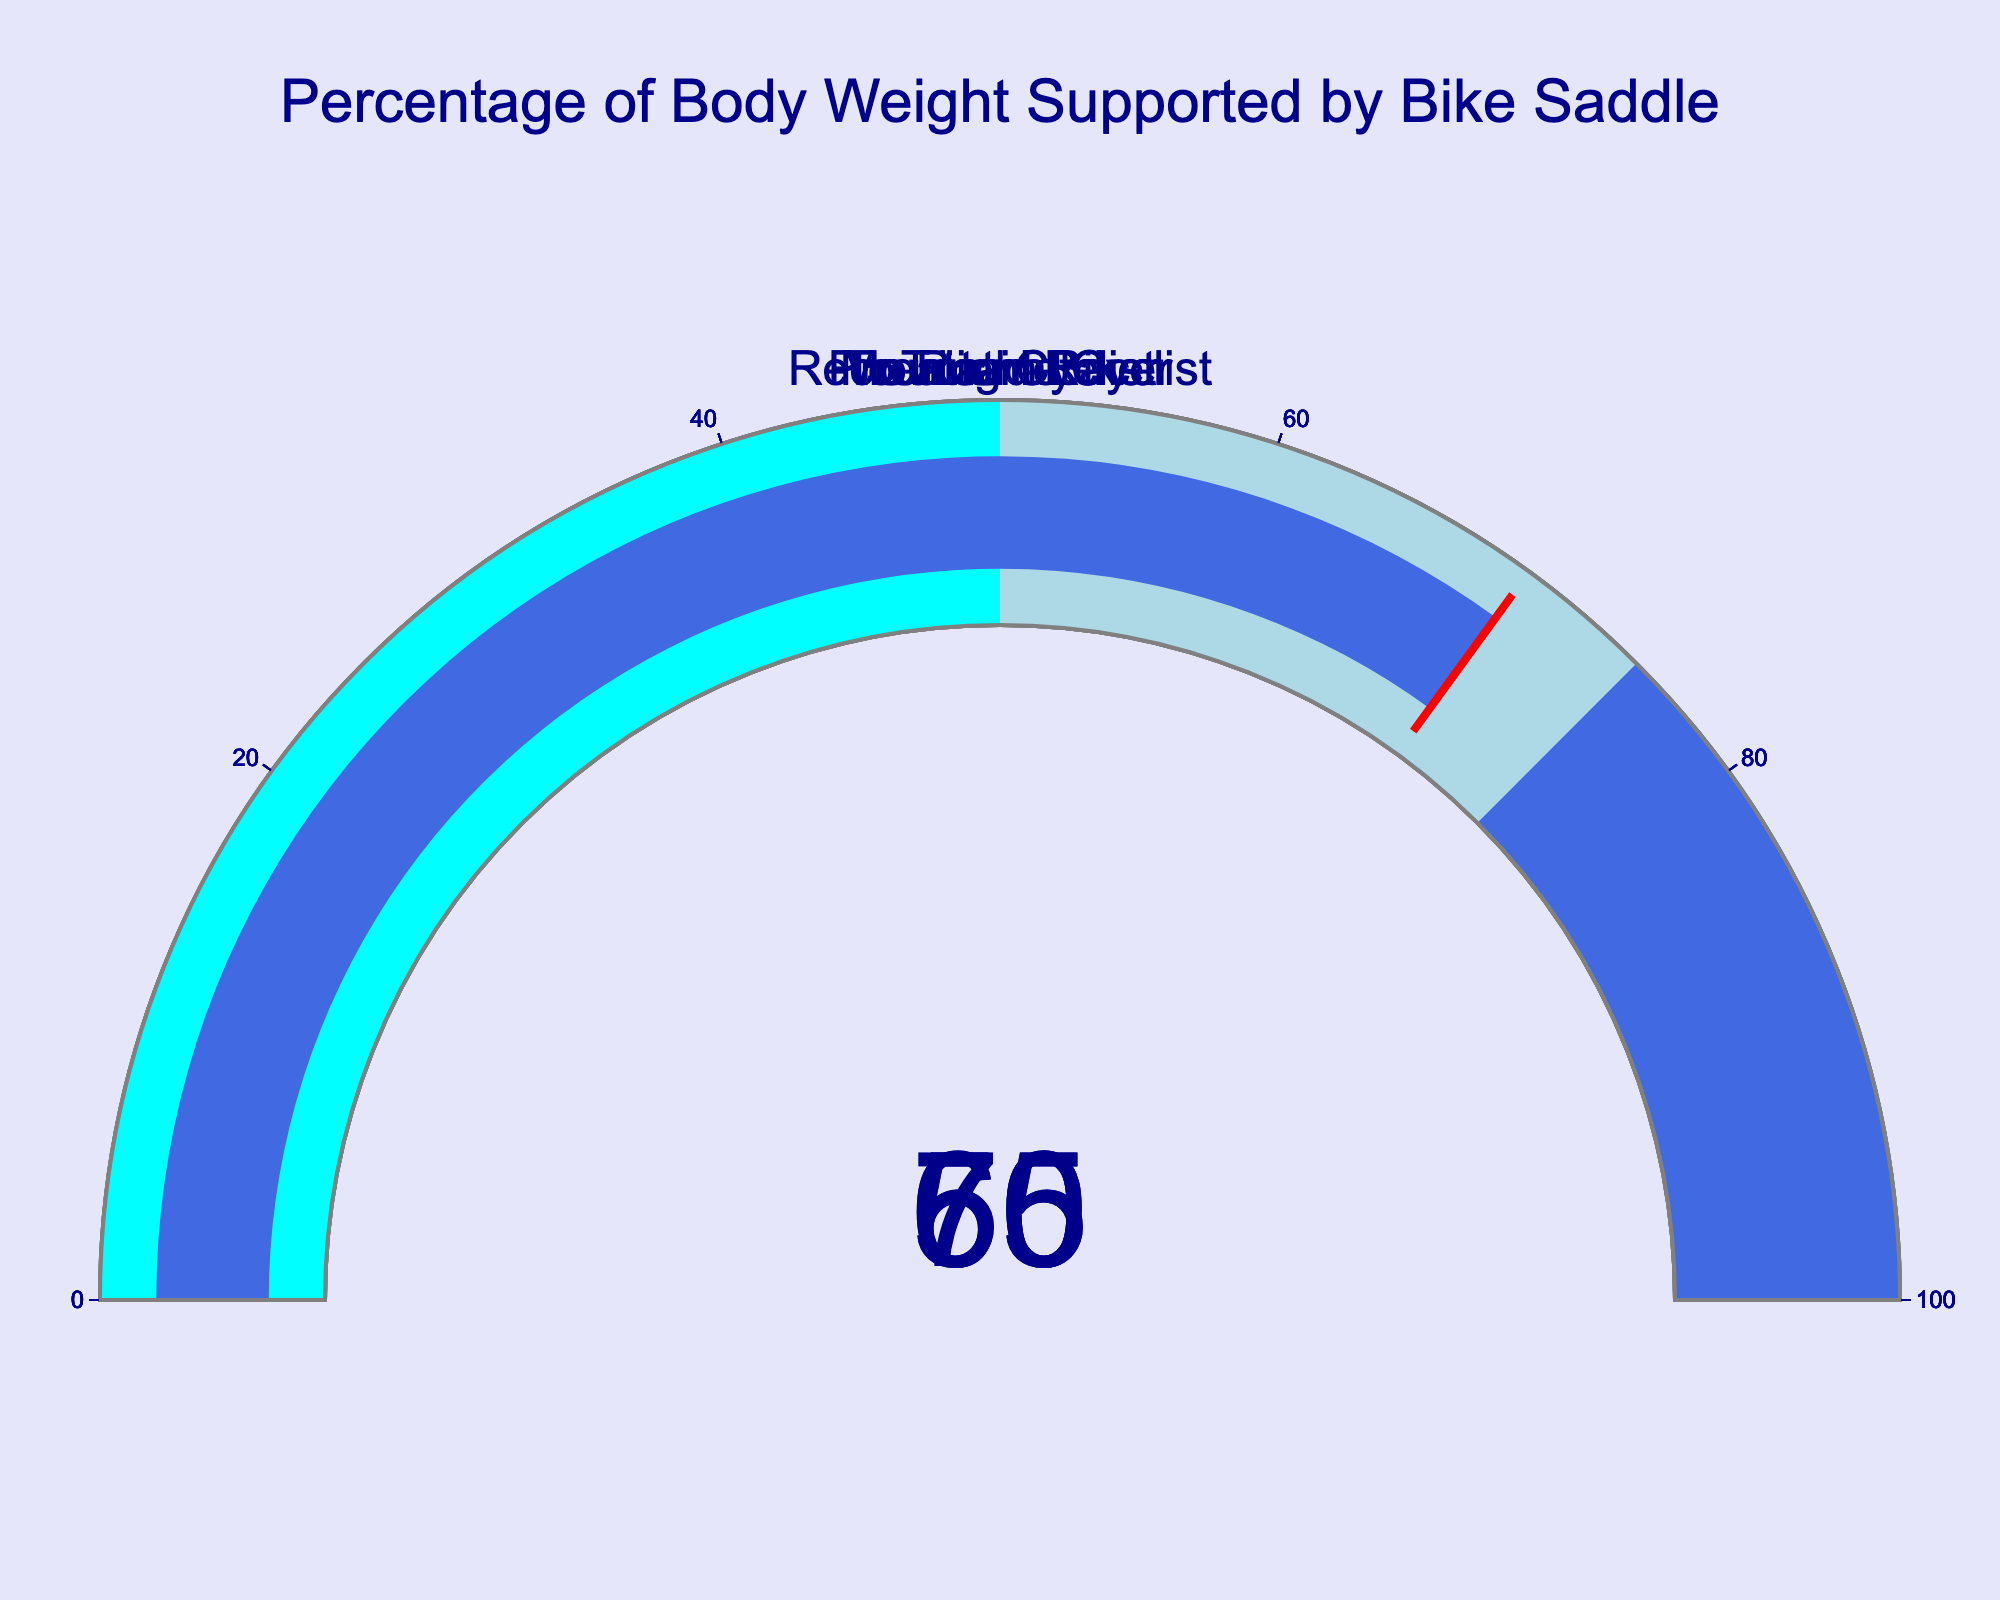Which cyclist type has the highest percentage of body weight supported by the saddle? To determine this, we have to compare the values of all gauges. The Touring Cyclist has the highest value at 70%.
Answer: Touring Cyclist Which cyclist type has the lowest percentage of body weight supported by the saddle? By looking at the figure, the Pro Road Racer supports 50%, which is the lowest among all cyclists.
Answer: Pro Road Racer What is the average percentage of body weight supported by the saddle across all cyclist types? Add the percentages: 60 (Recreational Cyclist) + 50 (Pro Road Racer) + 55 (Mountain Biker) + 65 (Triathlete) + 70 (Touring Cyclist) = 300. Then divide by the number of cyclist types: 300 / 5 = 60.
Answer: 60 How much more weight is supported by the Touring Cyclist compared to the Pro Road Racer? Subtract the percentage for the Pro Road Racer from that of the Touring Cyclist: 70 - 50 = 20.
Answer: 20 What's the median percentage of body weight supported by the saddle for all cyclist types? First, sort the percentages: 50 (Pro Road Racer), 55 (Mountain Biker), 60 (Recreational Cyclist), 65 (Triathlete), 70 (Touring Cyclist). The median is the middle value of the sorted list, which is 60.
Answer: 60 Which cyclist type supports 65% of their body weight on the saddle? From the figure, the Triathlete supports 65% of their body weight on the saddle.
Answer: Triathlete Is the percentage of body weight on the saddle for a Recreational Cyclist greater than that of a Pro Road Racer? Compare their respective percentages: 60 (Recreational Cyclist) is greater than 50 (Pro Road Racer).
Answer: Yes What is the range of percentages of body weight supported by the saddle across all cyclist types? Subtract the smallest percentage from the largest percentage: 70 (Touring Cyclist) - 50 (Pro Road Racer) = 20.
Answer: 20 Which cyclist types fall within the 50% to 75% range for the supported body weight? From the figure, Recreational Cyclist (60%), Pro Road Racer (50%), Mountain Biker (55%), and Triathlete (65%) fall within the 50-75% range.
Answer: Recreational Cyclist, Pro Road Racer, Mountain Biker, Triathlete 